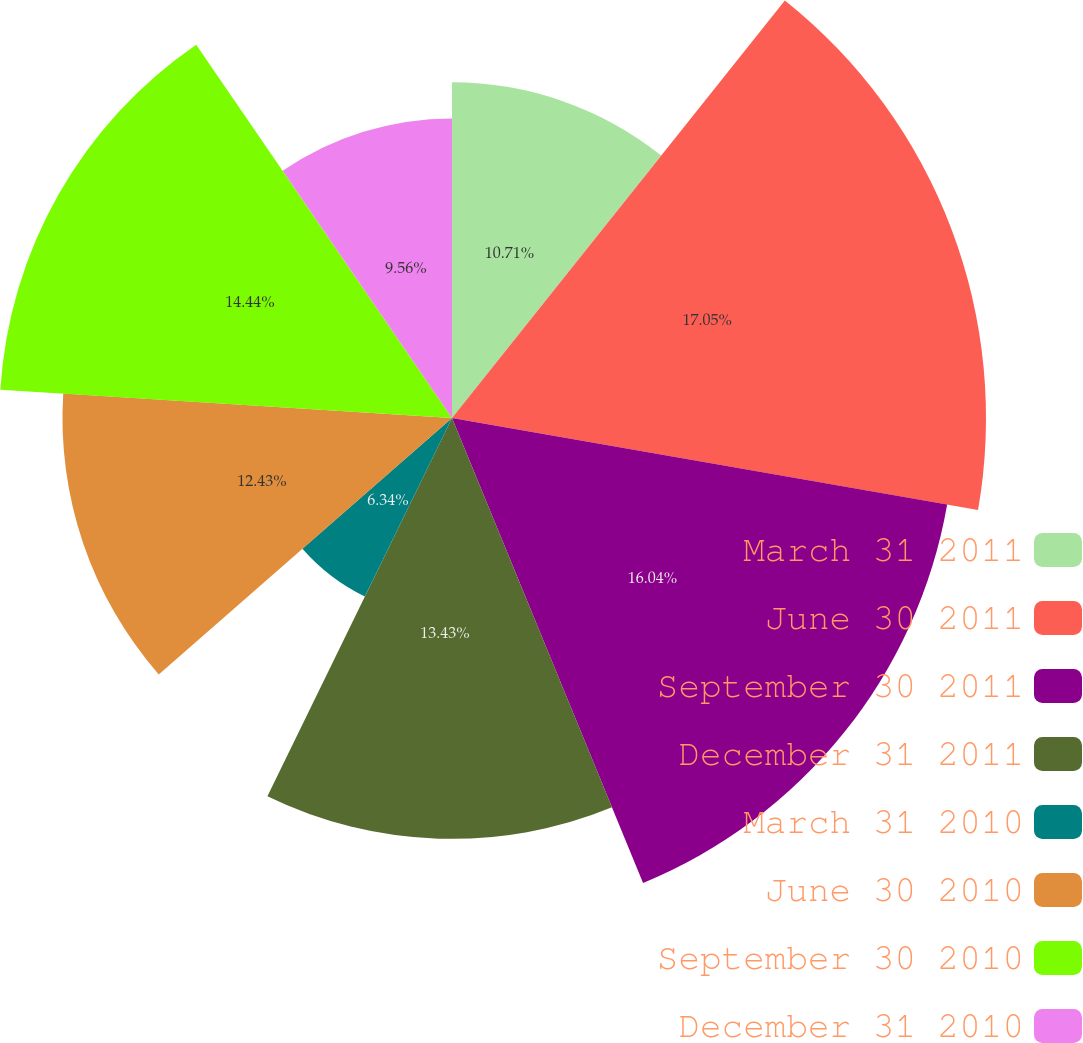<chart> <loc_0><loc_0><loc_500><loc_500><pie_chart><fcel>March 31 2011<fcel>June 30 2011<fcel>September 30 2011<fcel>December 31 2011<fcel>March 31 2010<fcel>June 30 2010<fcel>September 30 2010<fcel>December 31 2010<nl><fcel>10.71%<fcel>17.04%<fcel>16.04%<fcel>13.43%<fcel>6.34%<fcel>12.43%<fcel>14.44%<fcel>9.56%<nl></chart> 